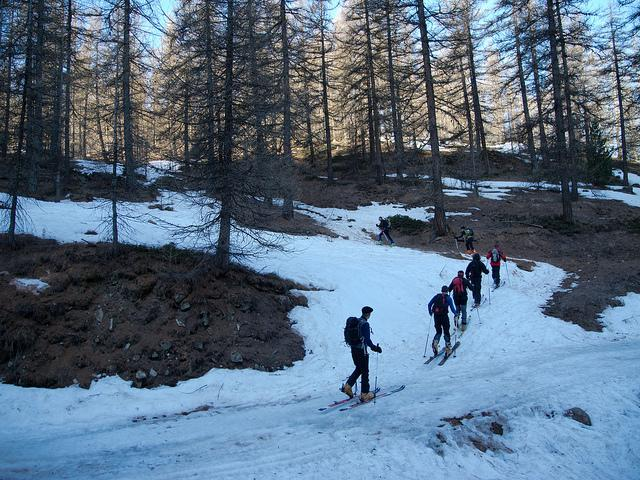Why are they skiing on level ground? cross country 